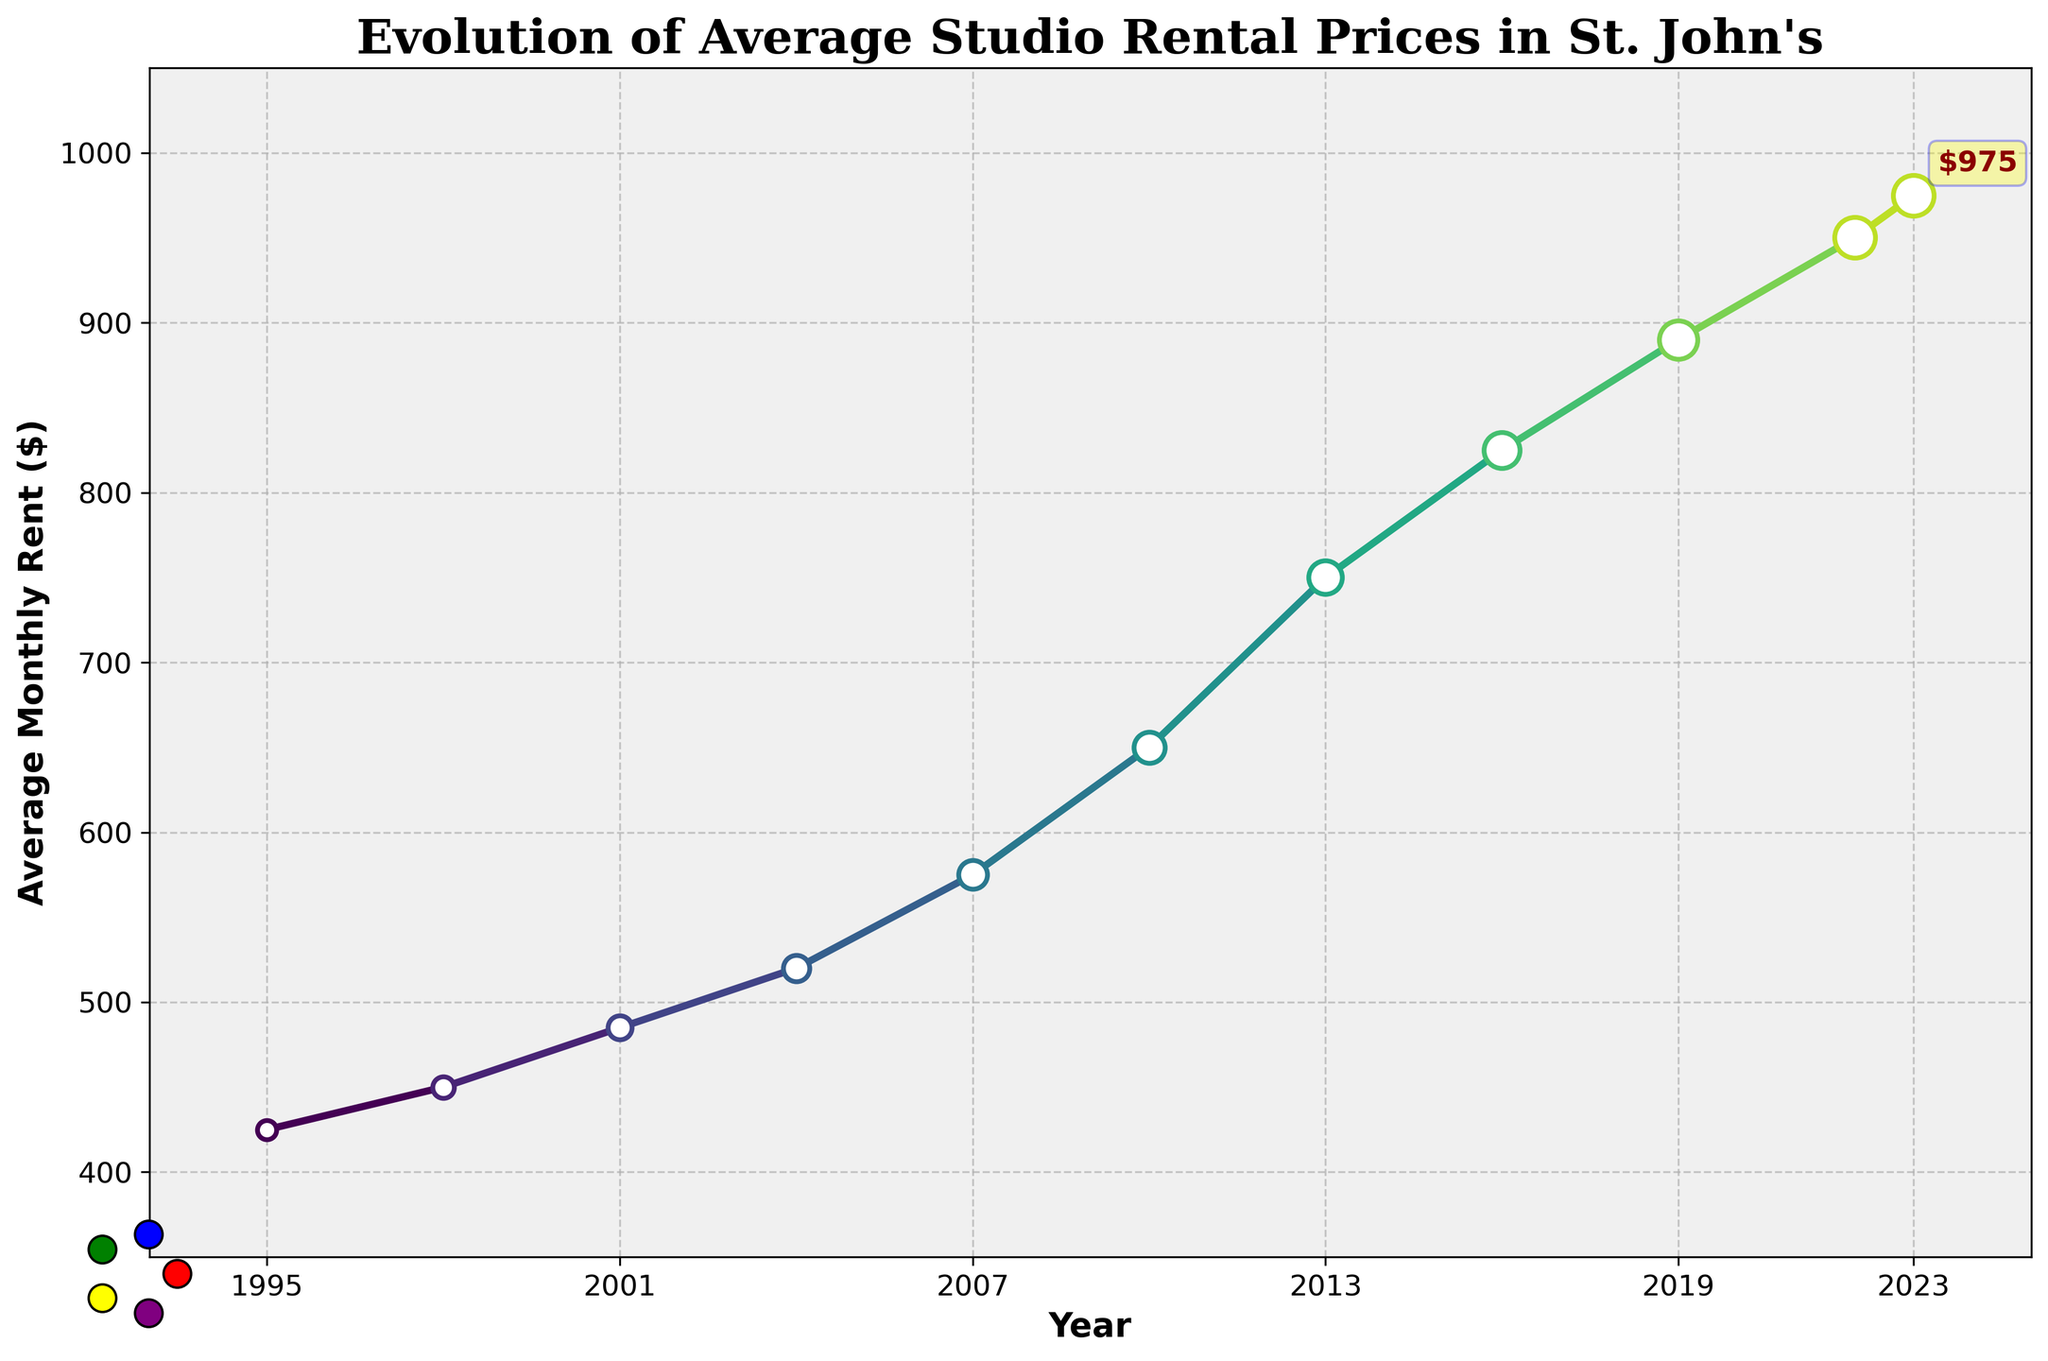What year shows the highest average rent? The chart indicates that the year 2023 shows the highest average monthly rent. Just follow the peak of the line chart to determine this.
Answer: 2023 How much did the average rent increase from 1995 to 2023? To find the total increase, subtract the rent in 1995 from the rent in 2023. The 2023 rent is $975, and the 1995 rent is $425. Therefore, $975 - $425 = $550.
Answer: $550 In which period was the largest increase in average rent observed? To identify the period with the largest increase, look for the steepest slope on the chart. The largest increase appears to be between 2007 and 2013, as the rent increased from $575 to $750.
Answer: 2007 to 2013 How many years did it take for the average rent to double from 1995's value? The rent in 1995 was $425. Doubling this value gives $850. Looking at the chart, this amount was reached around 2017. Thus, it took approximately 22 years (2017 - 1995).
Answer: 22 years What is the average annual rent increase over the entire period? The average annual increase is calculated by dividing the total rent increase by the number of years. The total increase is $975 - $425 = $550, and the number of years is 2023 - 1995 = 28. So, $550 / 28 ≈ $19.64 per year.
Answer: $19.64 per year By how much did the rent increase from 2001 to 2004? Subtract the rent in 2001 from the rent in 2004. The rent in 2001 was $485, and in 2004 it was $520, so $520 - $485 = $35.
Answer: $35 In which decade was the smallest increase in rent observed? Evaluate the increases in rent across each decade. The 1990s saw an increase of $25 ($450 - $425), the 2000s an increase of $130 ($650 - $520), and the 2010s an increase of $240 ($890 - $650). Thus, the smallest increase was in the 1990s.
Answer: The 1990s What is the visual marker size trend over the years? As per the plot details, markers gradually increase in size from 1995 to 2023, indicating a larger visual emphasis on more recent data points.
Answer: Increasing What is the color trend of the line from the beginning to the end? The plot uses a gradient color scheme that transitions smoothly through colors. Early years have a different color than later years due to the gradient effect.
Answer: Gradient from lighter to darker colors 